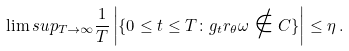Convert formula to latex. <formula><loc_0><loc_0><loc_500><loc_500>\lim s u p _ { T \rightarrow \infty } \frac { 1 } { T } \left | \{ 0 \leq t \leq T \colon g _ { t } r _ { \theta } \omega \notin C \} \right | \leq \eta \, .</formula> 